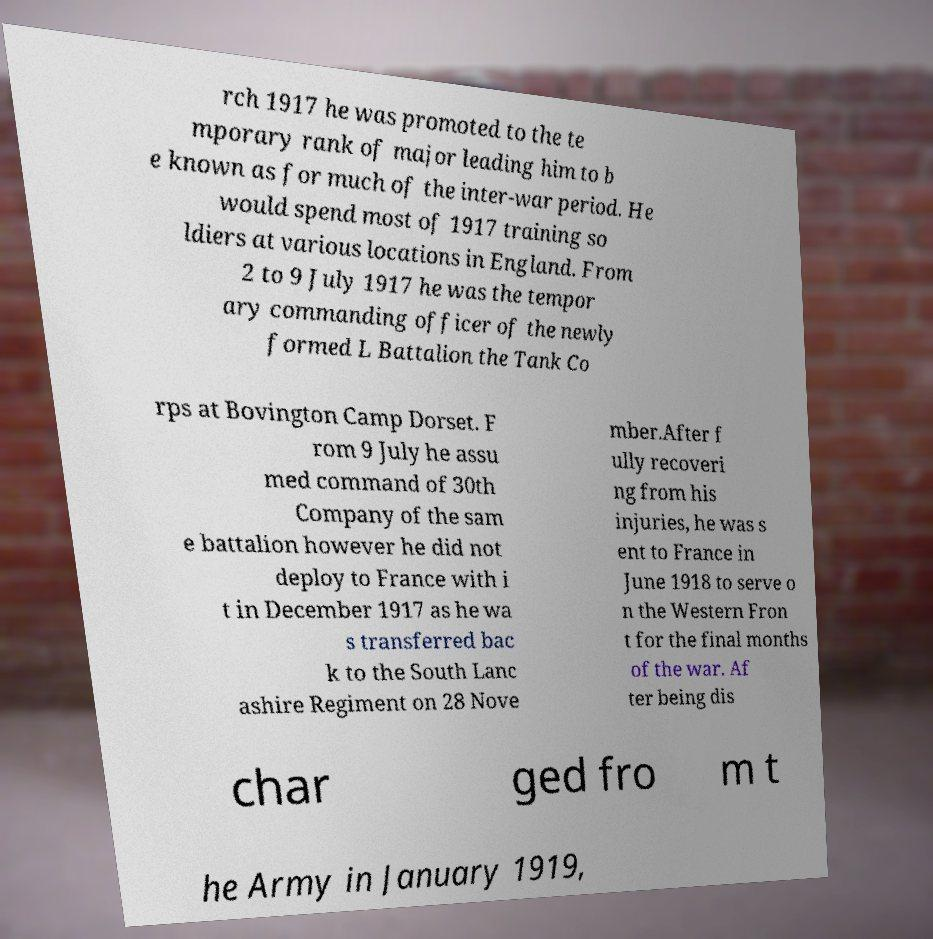Could you extract and type out the text from this image? rch 1917 he was promoted to the te mporary rank of major leading him to b e known as for much of the inter-war period. He would spend most of 1917 training so ldiers at various locations in England. From 2 to 9 July 1917 he was the tempor ary commanding officer of the newly formed L Battalion the Tank Co rps at Bovington Camp Dorset. F rom 9 July he assu med command of 30th Company of the sam e battalion however he did not deploy to France with i t in December 1917 as he wa s transferred bac k to the South Lanc ashire Regiment on 28 Nove mber.After f ully recoveri ng from his injuries, he was s ent to France in June 1918 to serve o n the Western Fron t for the final months of the war. Af ter being dis char ged fro m t he Army in January 1919, 